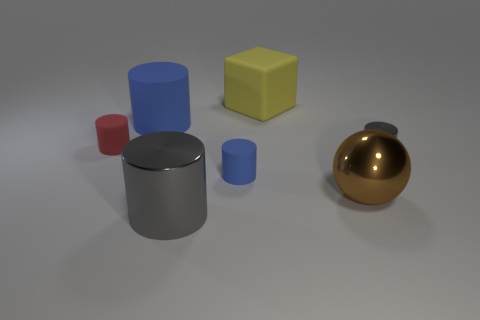Subtract all red cylinders. How many cylinders are left? 4 Subtract all large rubber cylinders. How many cylinders are left? 4 Subtract all green cylinders. Subtract all gray cubes. How many cylinders are left? 5 Add 2 small yellow shiny spheres. How many objects exist? 9 Subtract all spheres. How many objects are left? 6 Subtract all small blue cylinders. Subtract all brown metal objects. How many objects are left? 5 Add 1 tiny blue things. How many tiny blue things are left? 2 Add 1 large matte cubes. How many large matte cubes exist? 2 Subtract 0 brown cubes. How many objects are left? 7 